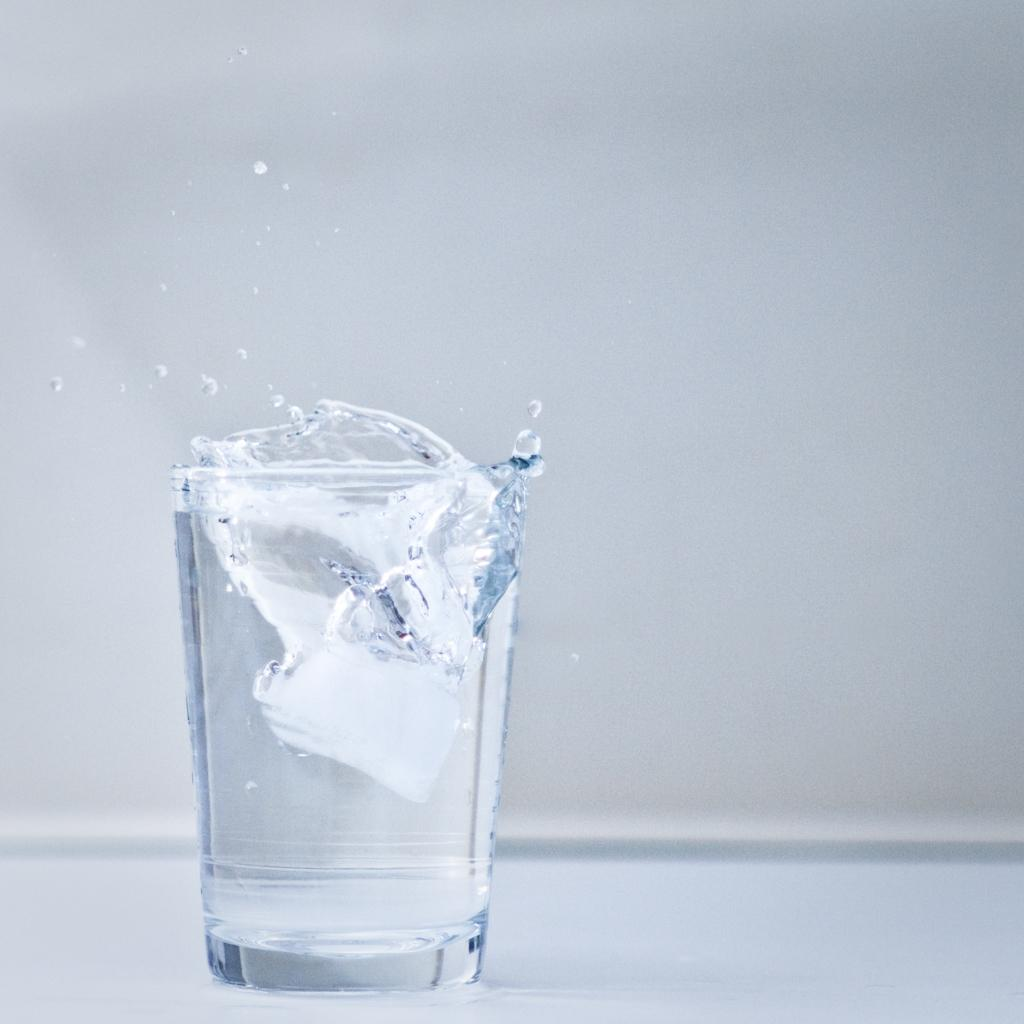What is present on the surface in the image? There is a glass on a white color surface in the image. What is inside the glass? There is water in the glass. What can be seen in the background of the image? There is a wall in the background of the image. What is the color of the wall? The wall is in white color. What type of learning is taking place in the image? There is no learning activity depicted in the image; it shows a glass with water on a white surface and a white wall in the background. Can you tell me where the game is being played in the image? There is no game being played in the image; it only features a glass with water on a white surface and a white wall in the background. 